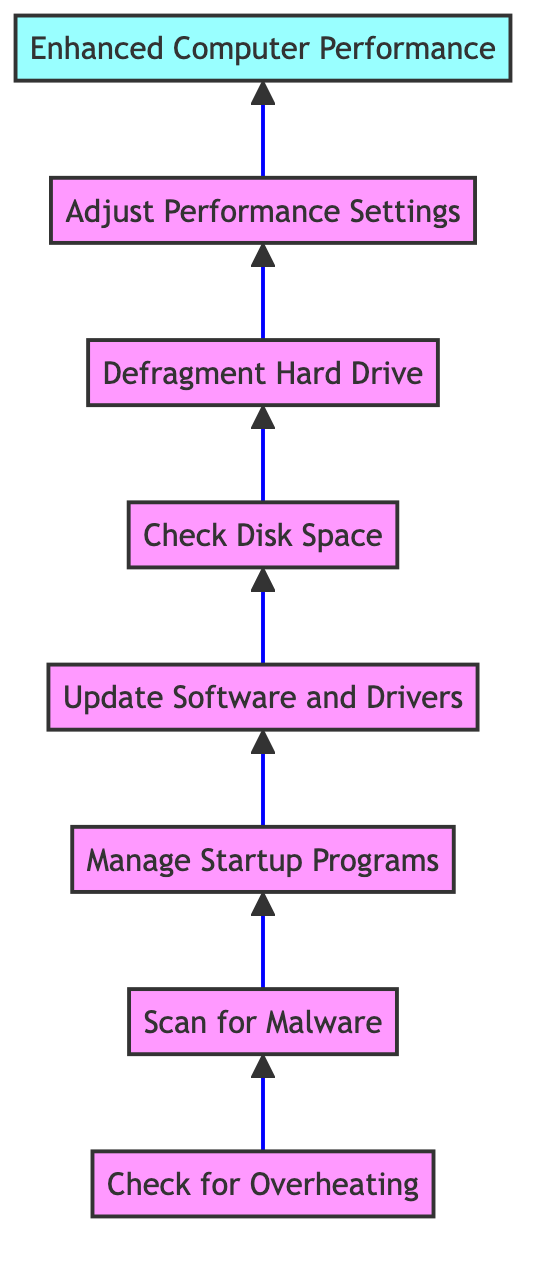What is the first step in the flow chart? The first step identified in the diagram is "Check for Overheating," which is the starting point of the process.
Answer: Check for Overheating How many steps are there in the flow chart? By counting each step from the beginning to the end, there are a total of seven steps before reaching the outcome.
Answer: Seven What is the outcome of following the steps in the diagram? The diagram concludes with an outcome node stating "Enhanced Computer Performance," which is the result of following all previous steps.
Answer: Enhanced Computer Performance Which step comes directly after "Scan for Malware"? The step that follows "Scan for Malware" in the flow chart is "Manage Startup Programs," indicating the next action to take.
Answer: Manage Startup Programs What tools are recommended for checking disk space? The flow chart specifies "Disk Cleanup" and "Storage Settings" as the tools to be used for checking disk space.
Answer: Disk Cleanup, Storage Settings If a user completes "Defragment Hard Drive," which step do they proceed to next? After completing "Defragment Hard Drive," the user would move to the next step, which is "Adjust Performance Settings," indicating a progression in the flow.
Answer: Adjust Performance Settings In the context of the flow chart, what type of diagram is it? The diagram is a "Bottom to Top Flow Chart," designed to depict a series of steps moving from the bottom upwards to the outcome.
Answer: Bottom to Top Flow Chart What is described in the "Adjust Performance Settings" step? This step advises modifying system settings for optimal performance, involving adjustments to visual effects and other configurations.
Answer: Modify system settings for best performance What does the "Check for Overheating" step require? For the "Check for Overheating" step, the recommended tools are "Temperature Monitoring Tools" and "Compressed Air," necessary for this check.
Answer: Temperature Monitoring Tools, Compressed Air 